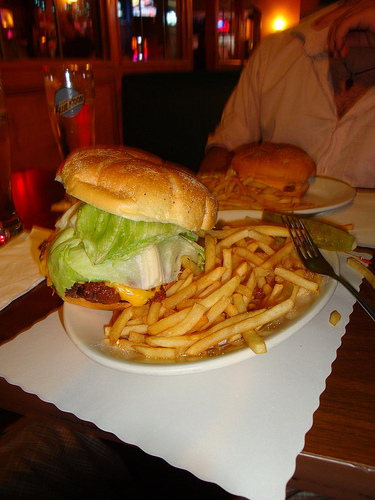<image>What is the website in the corner of the picture? There is no website in the corner of the picture. What is the website in the corner of the picture? There is no website in the corner of the picture. 